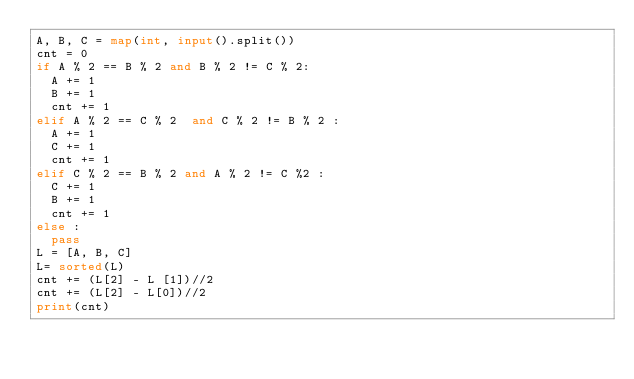Convert code to text. <code><loc_0><loc_0><loc_500><loc_500><_Python_>A, B, C = map(int, input().split())
cnt = 0
if A % 2 == B % 2 and B % 2 != C % 2:
  A += 1
  B += 1
  cnt += 1
elif A % 2 == C % 2  and C % 2 != B % 2 :
  A += 1
  C += 1
  cnt += 1
elif C % 2 == B % 2 and A % 2 != C %2 :
  C += 1
  B += 1
  cnt += 1
else :
  pass
L = [A, B, C]
L= sorted(L)
cnt += (L[2] - L [1])//2
cnt += (L[2] - L[0])//2
print(cnt)
</code> 